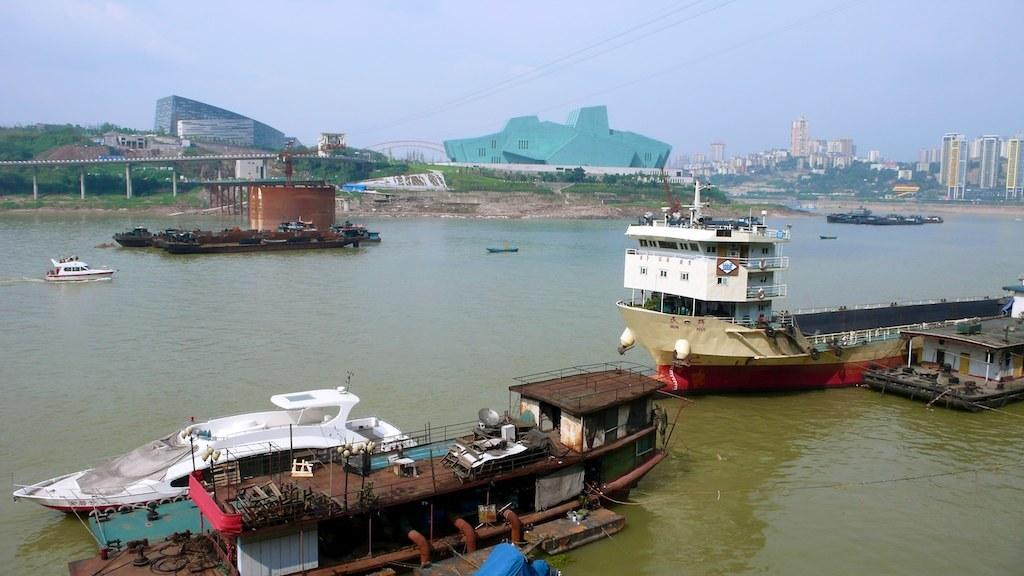What is the main subject of the image? There are many boats in the water. What can be seen in the background of the image? There is a bridge, trees, buildings, and the sky visible in the background of the image. How many corks can be seen floating in the water in the image? There are no corks visible in the image; it features boats in the water. What type of hill is present in the image? There is no hill present in the image; it features boats, a bridge, trees, buildings, and the sky. 